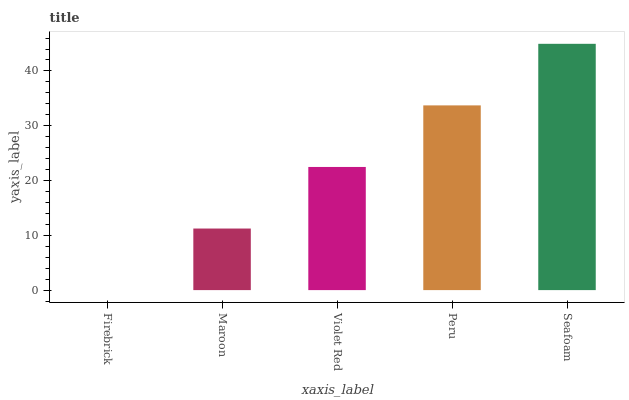Is Firebrick the minimum?
Answer yes or no. Yes. Is Seafoam the maximum?
Answer yes or no. Yes. Is Maroon the minimum?
Answer yes or no. No. Is Maroon the maximum?
Answer yes or no. No. Is Maroon greater than Firebrick?
Answer yes or no. Yes. Is Firebrick less than Maroon?
Answer yes or no. Yes. Is Firebrick greater than Maroon?
Answer yes or no. No. Is Maroon less than Firebrick?
Answer yes or no. No. Is Violet Red the high median?
Answer yes or no. Yes. Is Violet Red the low median?
Answer yes or no. Yes. Is Peru the high median?
Answer yes or no. No. Is Seafoam the low median?
Answer yes or no. No. 